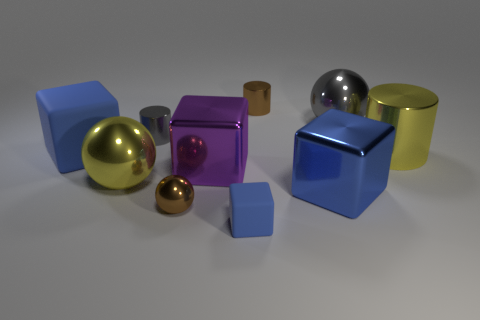There is a small thing that is the same color as the large rubber cube; what is its material?
Your answer should be very brief. Rubber. There is another purple thing that is the same shape as the big rubber thing; what material is it?
Your answer should be very brief. Metal. There is a large cube that is behind the big metal cylinder; does it have the same color as the large metal cube to the right of the small brown metal cylinder?
Give a very brief answer. Yes. Are there any other large gray balls made of the same material as the gray sphere?
Make the answer very short. No. Do the cube that is in front of the small sphere and the large rubber object have the same color?
Your answer should be very brief. Yes. Are there an equal number of brown objects in front of the tiny brown cylinder and blue matte cubes?
Give a very brief answer. No. Are there any small matte blocks of the same color as the large metal cylinder?
Your answer should be compact. No. Does the gray cylinder have the same size as the purple object?
Make the answer very short. No. What is the size of the blue matte cube that is to the left of the metal ball left of the small gray metallic cylinder?
Offer a very short reply. Large. There is a shiny ball that is to the right of the small gray thing and in front of the big matte block; what is its size?
Offer a very short reply. Small. 